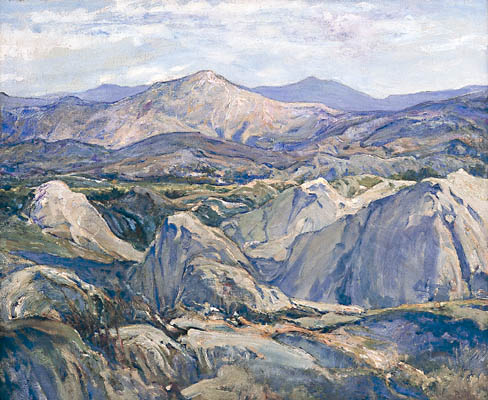Describe a short adventure you might have in this landscape. Imagine embarking on a short, invigorating hike through this landscape. With a backpack filled with essentials, I set off at dawn. The cool morning air is refreshing, and the sky is painted with the soft colors of dawn. I follow an old trail that winds through the hills, each turn revealing new breathtaking vistas.

After several hours of hiking, I come across a hidden glade, where a crystal-clear stream flows gently. It’s the perfect spot to rest and have a picnic. The tranquility of the location is captivating, making me lose track of time. As the sun reaches its zenith, I decide to explore a little further, climbing a nearby hill that offers an even more stunning view of the surrounding mountains.

After soaking in the panorama and taking numerous photos, I make my way back, feeling refreshed and grateful for the chance to connect so deeply with nature. The day ends with a sense of accomplishment and a vow to return to this serene and beautiful place. 